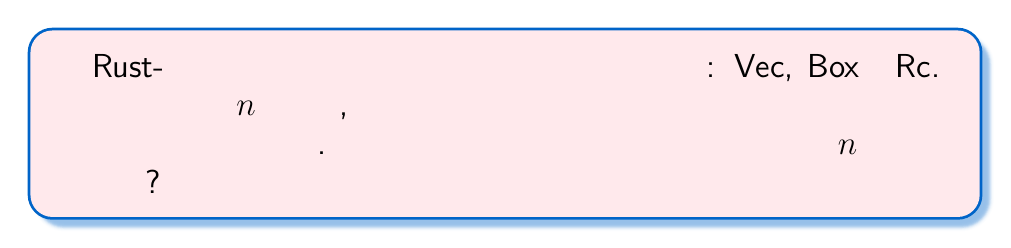What is the answer to this math problem? Для решения этой задачи воспользуемся следующими шагами:

1) Каждый из $n$ объектов может быть размещен одним из трех способов (Vec, Box или Rc).

2) Выбор способа размещения для каждого объекта не зависит от выбора для других объектов.

3) Это классический пример задачи на правило умножения в комбинаторике.

4) Для каждого из $n$ объектов у нас есть 3 варианта выбора.

5) Согласно правилу умножения, общее количество способов равно произведению количества вариантов для каждого выбора.

6) Таким образом, общее количество способов размещения $n$ объектов равно:

   $$3 \cdot 3 \cdot ... \cdot 3$$ (n раз)

7) Это можно записать как $3^n$.

Итак, существует $3^n$ различных способов размещения $n$ объектов в памяти, используя Vec, Box и Rc.
Answer: $3^n$ 